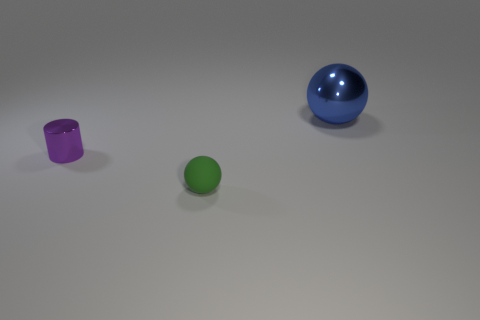Add 3 green matte things. How many objects exist? 6 Subtract all cylinders. How many objects are left? 2 Subtract 2 spheres. How many spheres are left? 0 Subtract 0 gray balls. How many objects are left? 3 Subtract all red cylinders. Subtract all blue balls. How many cylinders are left? 1 Subtract all gray cubes. Subtract all balls. How many objects are left? 1 Add 2 purple metallic things. How many purple metallic things are left? 3 Add 2 big blue shiny spheres. How many big blue shiny spheres exist? 3 